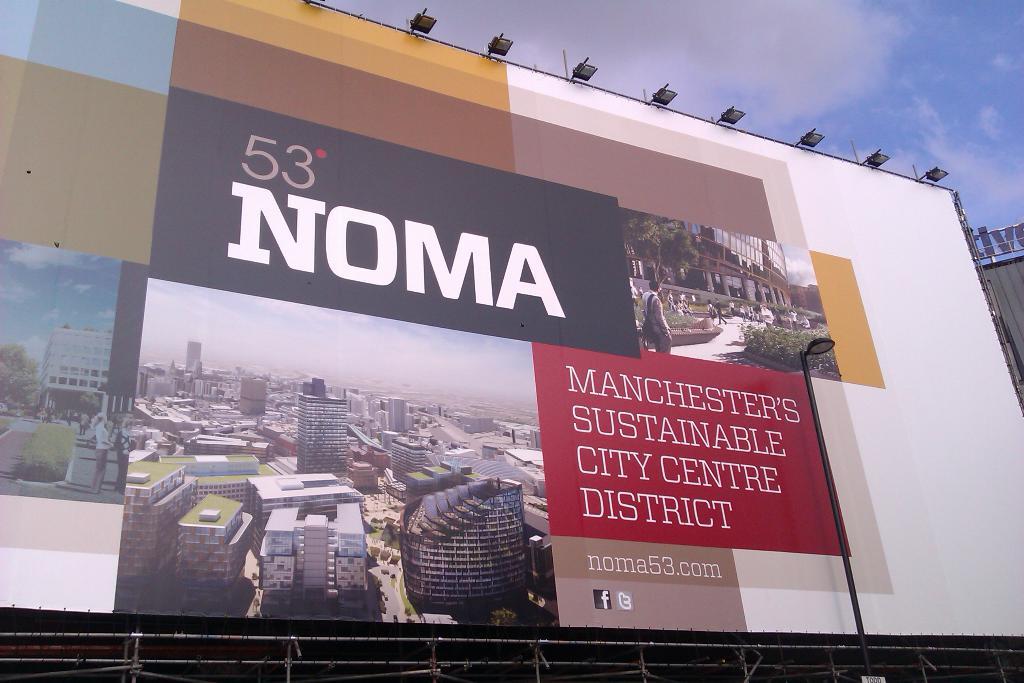What number is at the top of the sign?
Your response must be concise. 53. What is the website mentioned?
Your answer should be compact. Noma53.com. 